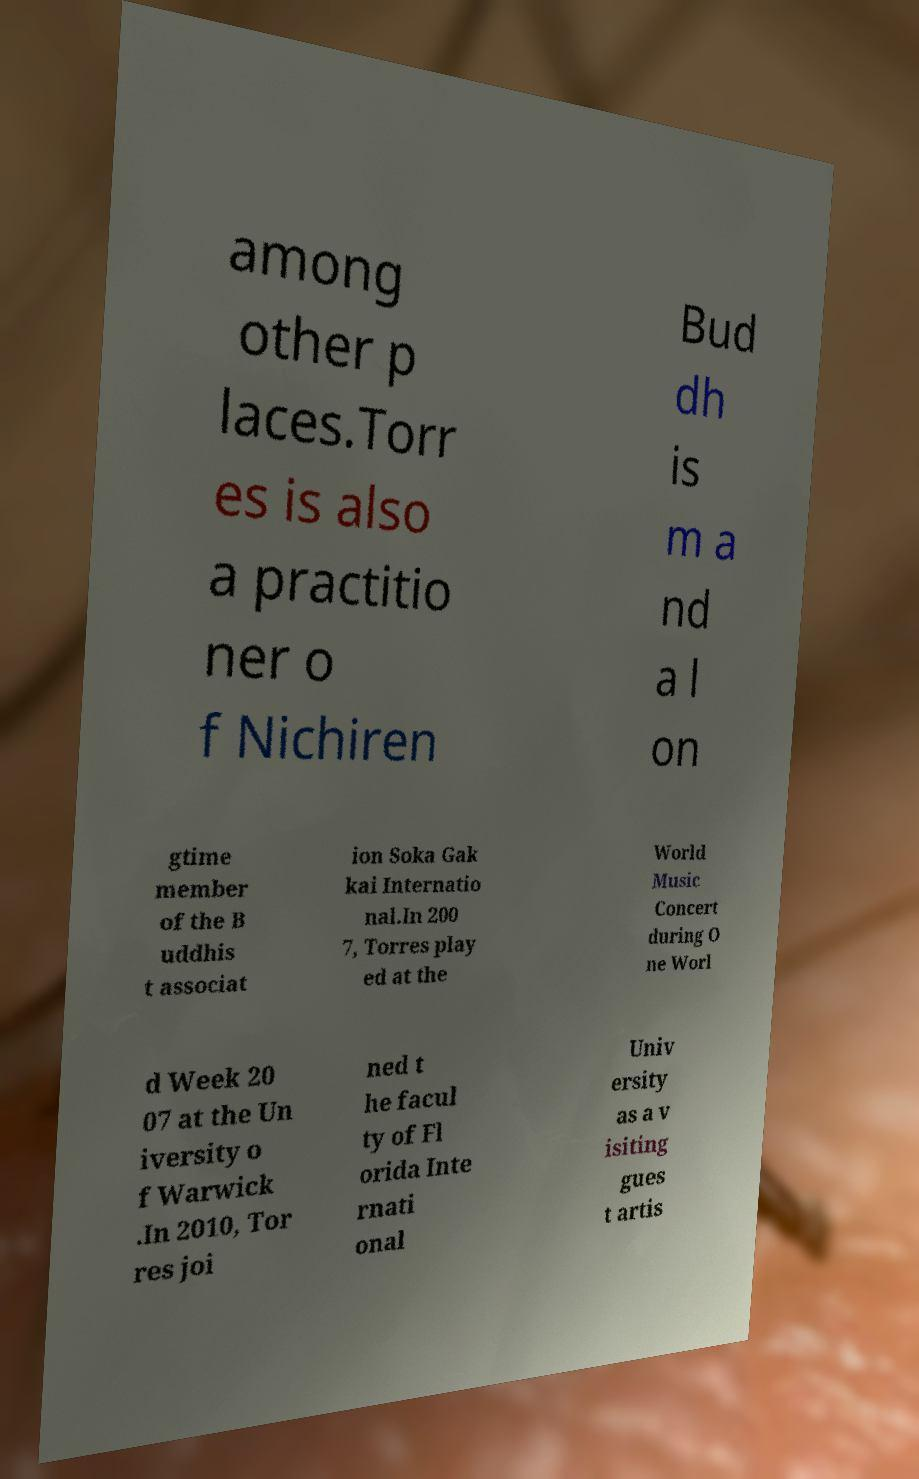Can you read and provide the text displayed in the image?This photo seems to have some interesting text. Can you extract and type it out for me? among other p laces.Torr es is also a practitio ner o f Nichiren Bud dh is m a nd a l on gtime member of the B uddhis t associat ion Soka Gak kai Internatio nal.In 200 7, Torres play ed at the World Music Concert during O ne Worl d Week 20 07 at the Un iversity o f Warwick .In 2010, Tor res joi ned t he facul ty of Fl orida Inte rnati onal Univ ersity as a v isiting gues t artis 